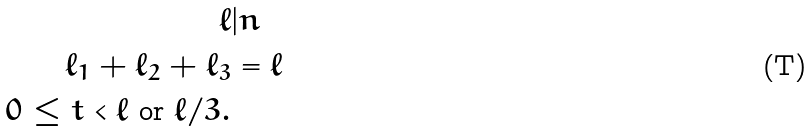<formula> <loc_0><loc_0><loc_500><loc_500>\ell & | n \\ \ell _ { 1 } + \ell _ { 2 } + \ell _ { 3 } & = \ell \\ 0 \leq t < \ell \text { or } \ell / 3 .</formula> 